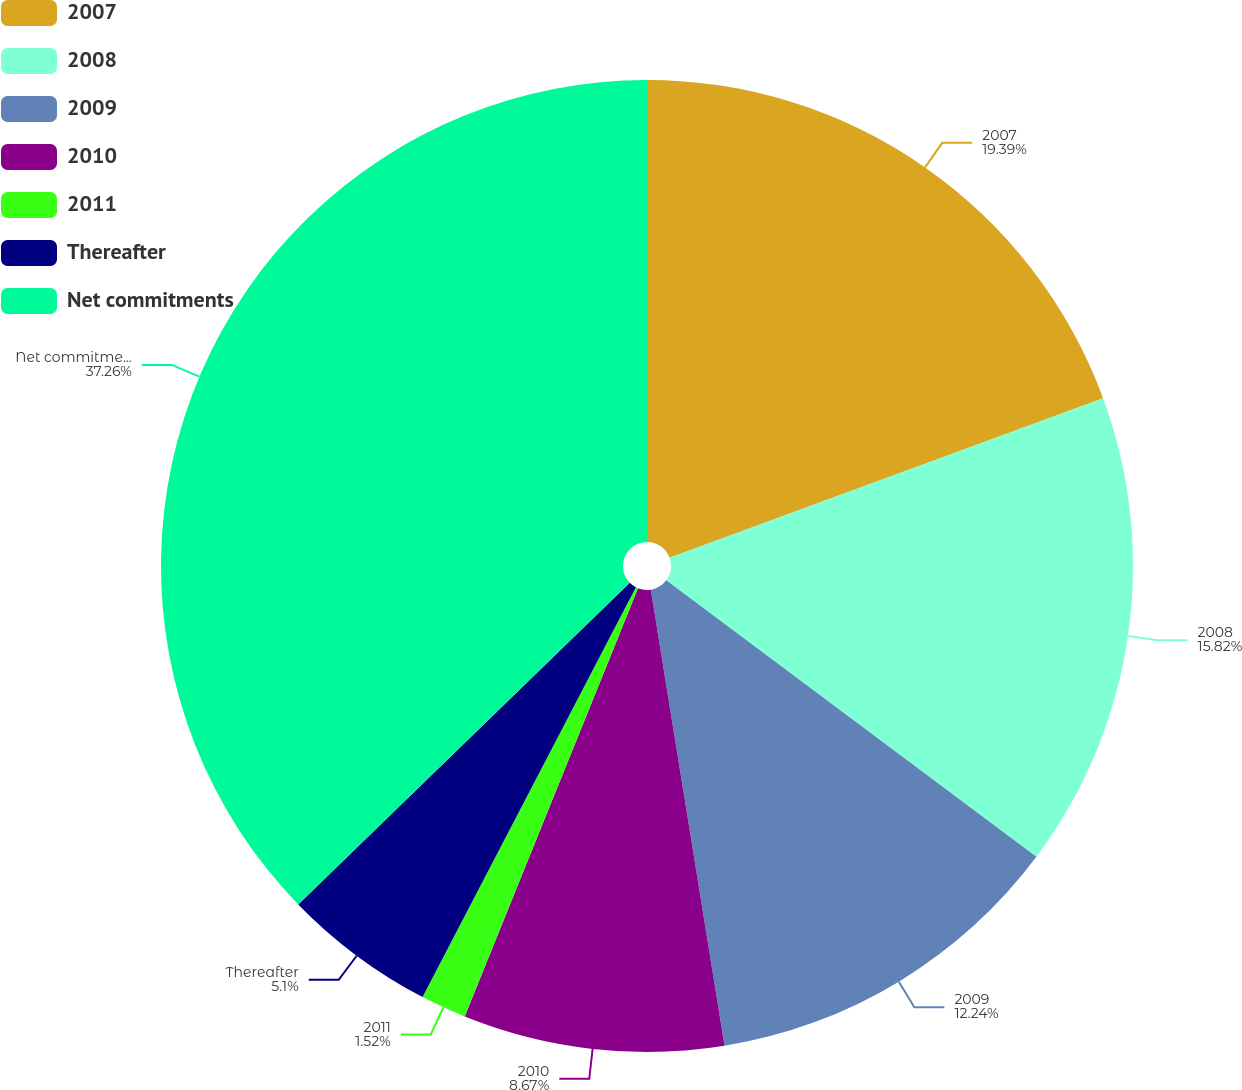<chart> <loc_0><loc_0><loc_500><loc_500><pie_chart><fcel>2007<fcel>2008<fcel>2009<fcel>2010<fcel>2011<fcel>Thereafter<fcel>Net commitments<nl><fcel>19.39%<fcel>15.82%<fcel>12.24%<fcel>8.67%<fcel>1.52%<fcel>5.1%<fcel>37.26%<nl></chart> 